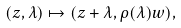Convert formula to latex. <formula><loc_0><loc_0><loc_500><loc_500>( z , \lambda ) \mapsto ( z + \lambda , \rho ( \lambda ) w ) ,</formula> 